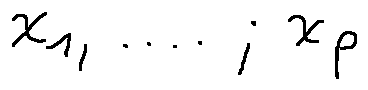Convert formula to latex. <formula><loc_0><loc_0><loc_500><loc_500>X _ { 1 } , \dots , X _ { p }</formula> 